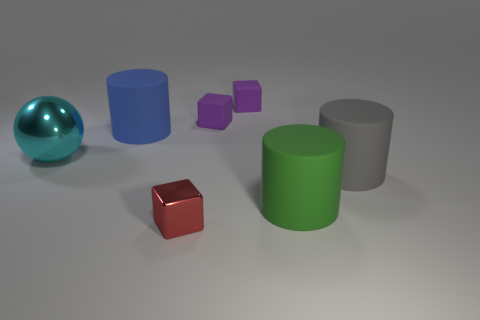Can you tell me which objects are reflective and which are matte? Certainly! The sphere on the left exhibits a reflective surface, noticeable by the light and environment reflections on it. The other objects in the image, including the cylinders and cubes, display matte surfaces with diffused reflection, absent of any clear reflections or mirror-like qualities. 